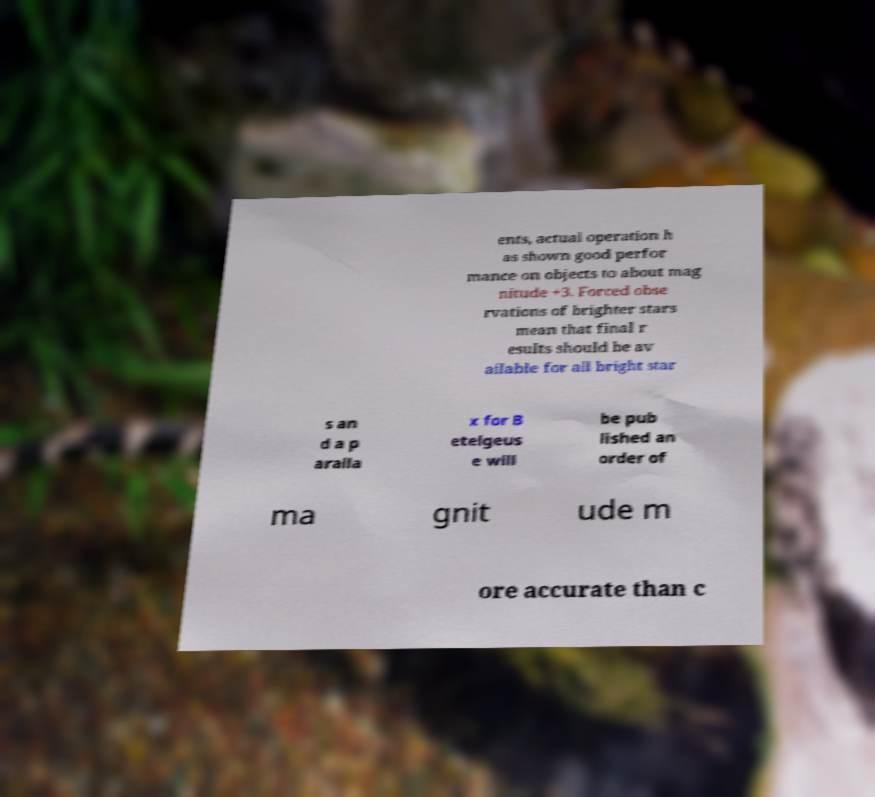Can you read and provide the text displayed in the image?This photo seems to have some interesting text. Can you extract and type it out for me? ents, actual operation h as shown good perfor mance on objects to about mag nitude +3. Forced obse rvations of brighter stars mean that final r esults should be av ailable for all bright star s an d a p aralla x for B etelgeus e will be pub lished an order of ma gnit ude m ore accurate than c 